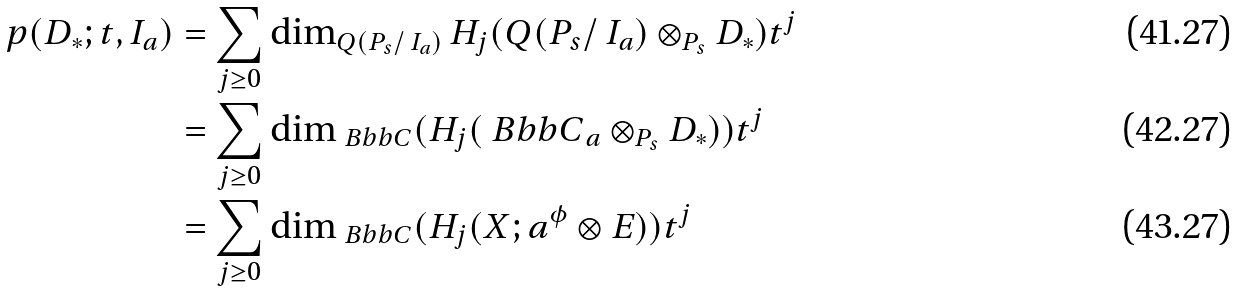<formula> <loc_0><loc_0><loc_500><loc_500>p ( D _ { * } ; t , I _ { a } ) & = \sum _ { j \geq 0 } \dim _ { Q ( P _ { s } / \, I _ { a } ) } { H _ { j } ( Q ( P _ { s } / \, I _ { a } ) \otimes _ { P _ { s } } D _ { * } ) } t ^ { j } \\ & = \sum _ { j \geq 0 } \dim _ { \ B b b C } ( H _ { j } ( { \ B b b C } _ { a } \otimes _ { P _ { s } } D _ { * } ) ) t ^ { j } \\ & = \sum _ { j \geq 0 } \dim _ { \ B b b C } ( H _ { j } ( X ; a ^ { \phi } \otimes E ) ) t ^ { j }</formula> 